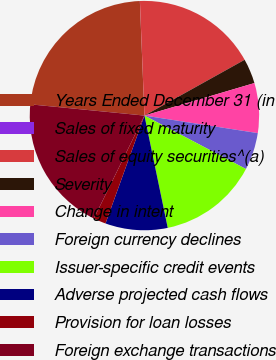Convert chart to OTSL. <chart><loc_0><loc_0><loc_500><loc_500><pie_chart><fcel>Years Ended December 31 (in<fcel>Sales of fixed maturity<fcel>Sales of equity securities^(a)<fcel>Severity<fcel>Change in intent<fcel>Foreign currency declines<fcel>Issuer-specific credit events<fcel>Adverse projected cash flows<fcel>Provision for loan losses<fcel>Foreign exchange transactions<nl><fcel>22.8%<fcel>0.01%<fcel>17.54%<fcel>3.51%<fcel>7.02%<fcel>5.27%<fcel>14.03%<fcel>8.77%<fcel>1.76%<fcel>19.29%<nl></chart> 